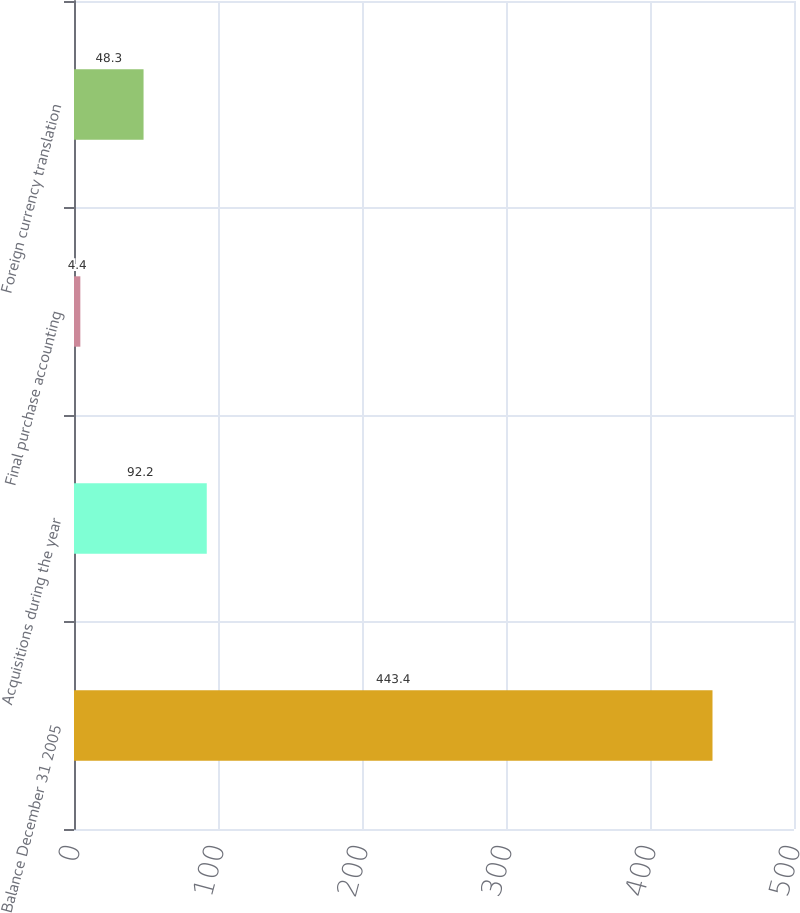Convert chart. <chart><loc_0><loc_0><loc_500><loc_500><bar_chart><fcel>Balance December 31 2005<fcel>Acquisitions during the year<fcel>Final purchase accounting<fcel>Foreign currency translation<nl><fcel>443.4<fcel>92.2<fcel>4.4<fcel>48.3<nl></chart> 